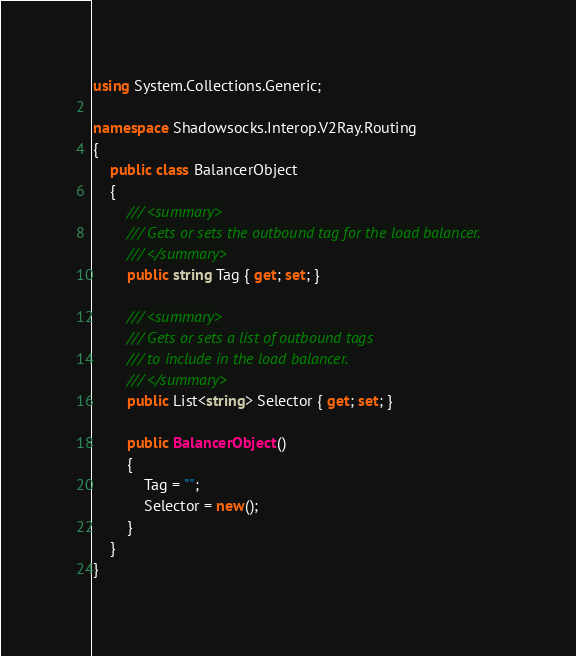Convert code to text. <code><loc_0><loc_0><loc_500><loc_500><_C#_>using System.Collections.Generic;

namespace Shadowsocks.Interop.V2Ray.Routing
{
    public class BalancerObject
    {
        /// <summary>
        /// Gets or sets the outbound tag for the load balancer.
        /// </summary>
        public string Tag { get; set; }

        /// <summary>
        /// Gets or sets a list of outbound tags
        /// to include in the load balancer.
        /// </summary>
        public List<string> Selector { get; set; }

        public BalancerObject()
        {
            Tag = "";
            Selector = new();
        }
    }
}
</code> 